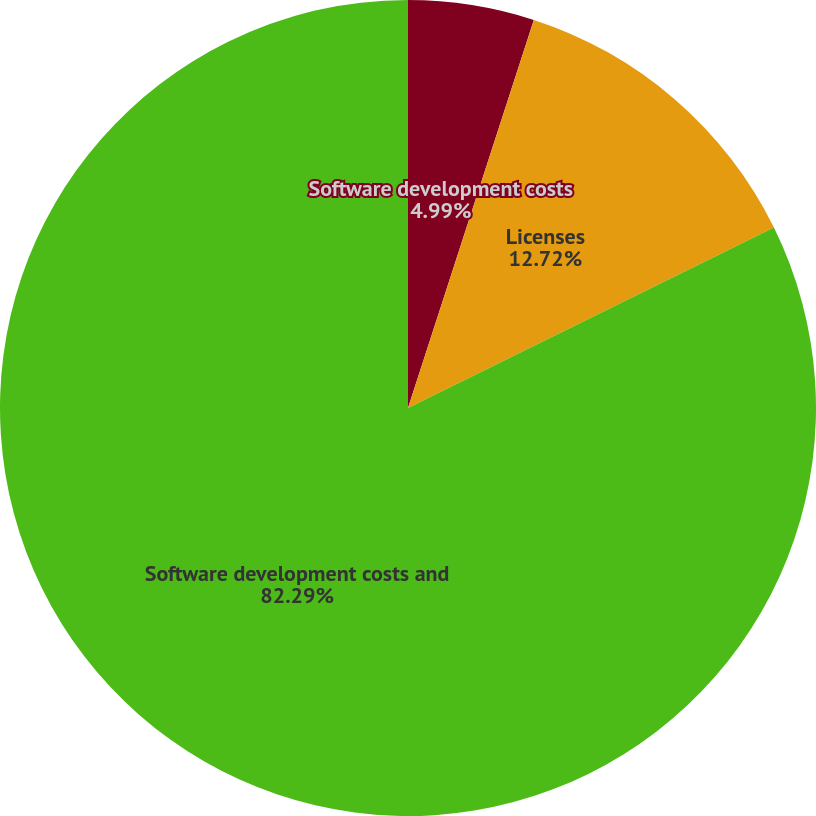Convert chart to OTSL. <chart><loc_0><loc_0><loc_500><loc_500><pie_chart><fcel>Software development costs<fcel>Licenses<fcel>Software development costs and<nl><fcel>4.99%<fcel>12.72%<fcel>82.29%<nl></chart> 